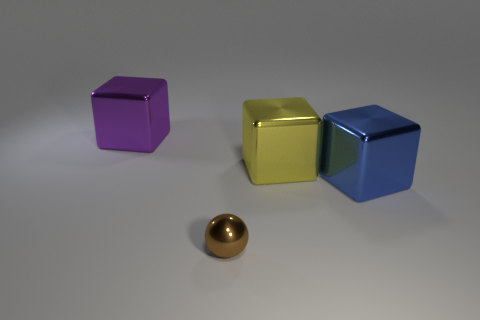Add 4 big metallic objects. How many objects exist? 8 Subtract all spheres. How many objects are left? 3 Subtract 0 gray cubes. How many objects are left? 4 Subtract all large purple blocks. Subtract all brown rubber cylinders. How many objects are left? 3 Add 3 blue metal blocks. How many blue metal blocks are left? 4 Add 4 shiny cylinders. How many shiny cylinders exist? 4 